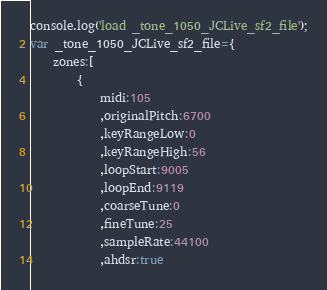<code> <loc_0><loc_0><loc_500><loc_500><_JavaScript_>console.log('load _tone_1050_JCLive_sf2_file');
var _tone_1050_JCLive_sf2_file={
	zones:[
		{
			midi:105
			,originalPitch:6700
			,keyRangeLow:0
			,keyRangeHigh:56
			,loopStart:9005
			,loopEnd:9119
			,coarseTune:0
			,fineTune:25
			,sampleRate:44100
			,ahdsr:true</code> 